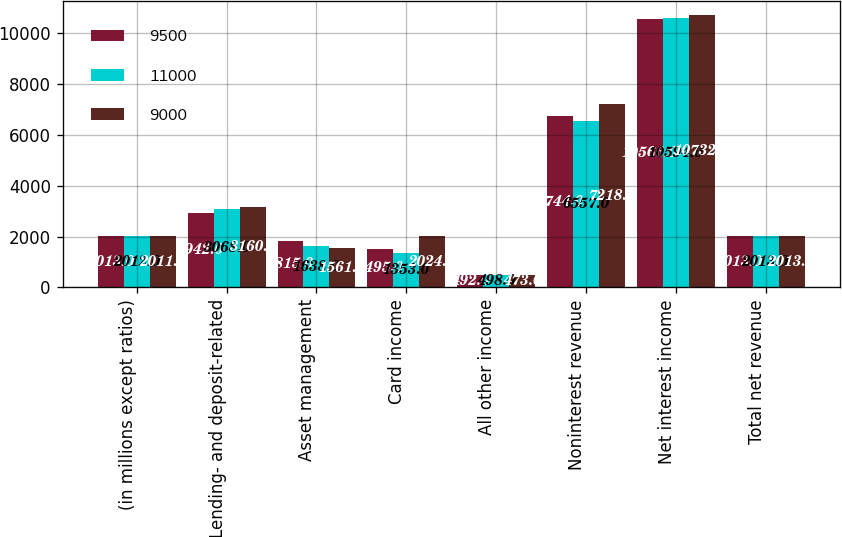<chart> <loc_0><loc_0><loc_500><loc_500><stacked_bar_chart><ecel><fcel>(in millions except ratios)<fcel>Lending- and deposit-related<fcel>Asset management<fcel>Card income<fcel>All other income<fcel>Noninterest revenue<fcel>Net interest income<fcel>Total net revenue<nl><fcel>9500<fcel>2013<fcel>2942<fcel>1815<fcel>1495<fcel>492<fcel>6744<fcel>10566<fcel>2013<nl><fcel>11000<fcel>2012<fcel>3068<fcel>1638<fcel>1353<fcel>498<fcel>6557<fcel>10594<fcel>2013<nl><fcel>9000<fcel>2011<fcel>3160<fcel>1561<fcel>2024<fcel>473<fcel>7218<fcel>10732<fcel>2013<nl></chart> 